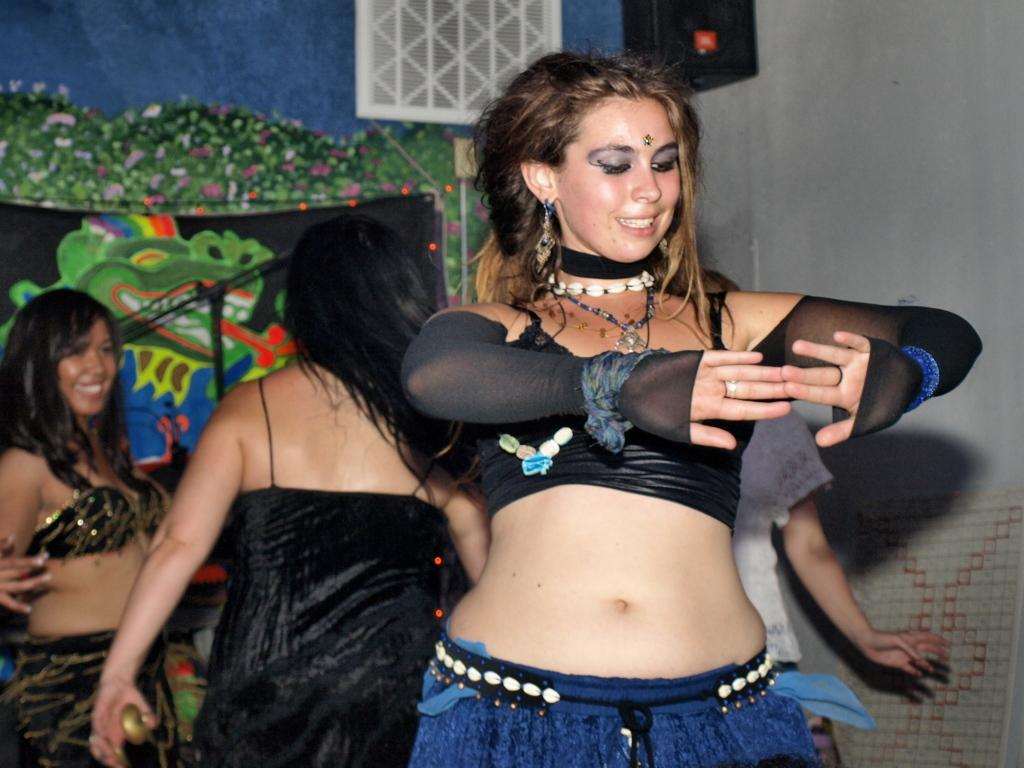Who is present in the image? There are women in the image. What can be seen in the background of the image? There is a cloth and a wall in the background of the image. What type of yam is being used as a prop in the image? There is no yam present in the image. What scientific experiment is being conducted in the image? There is no scientific experiment depicted in the image. 